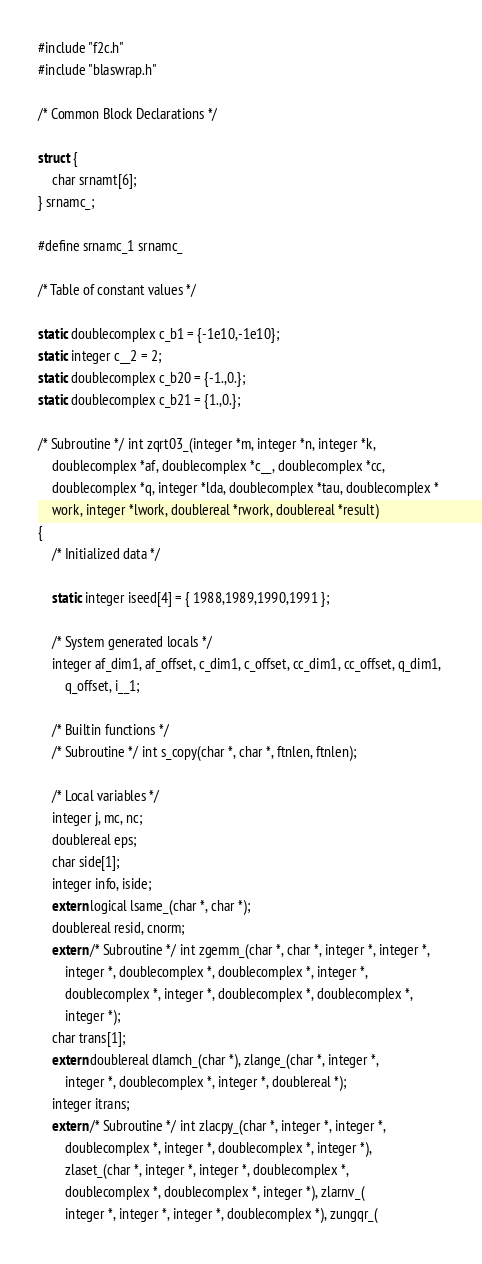Convert code to text. <code><loc_0><loc_0><loc_500><loc_500><_C_>#include "f2c.h"
#include "blaswrap.h"

/* Common Block Declarations */

struct {
    char srnamt[6];
} srnamc_;

#define srnamc_1 srnamc_

/* Table of constant values */

static doublecomplex c_b1 = {-1e10,-1e10};
static integer c__2 = 2;
static doublecomplex c_b20 = {-1.,0.};
static doublecomplex c_b21 = {1.,0.};

/* Subroutine */ int zqrt03_(integer *m, integer *n, integer *k, 
	doublecomplex *af, doublecomplex *c__, doublecomplex *cc, 
	doublecomplex *q, integer *lda, doublecomplex *tau, doublecomplex *
	work, integer *lwork, doublereal *rwork, doublereal *result)
{
    /* Initialized data */

    static integer iseed[4] = { 1988,1989,1990,1991 };

    /* System generated locals */
    integer af_dim1, af_offset, c_dim1, c_offset, cc_dim1, cc_offset, q_dim1, 
	    q_offset, i__1;

    /* Builtin functions */
    /* Subroutine */ int s_copy(char *, char *, ftnlen, ftnlen);

    /* Local variables */
    integer j, mc, nc;
    doublereal eps;
    char side[1];
    integer info, iside;
    extern logical lsame_(char *, char *);
    doublereal resid, cnorm;
    extern /* Subroutine */ int zgemm_(char *, char *, integer *, integer *, 
	    integer *, doublecomplex *, doublecomplex *, integer *, 
	    doublecomplex *, integer *, doublecomplex *, doublecomplex *, 
	    integer *);
    char trans[1];
    extern doublereal dlamch_(char *), zlange_(char *, integer *, 
	    integer *, doublecomplex *, integer *, doublereal *);
    integer itrans;
    extern /* Subroutine */ int zlacpy_(char *, integer *, integer *, 
	    doublecomplex *, integer *, doublecomplex *, integer *), 
	    zlaset_(char *, integer *, integer *, doublecomplex *, 
	    doublecomplex *, doublecomplex *, integer *), zlarnv_(
	    integer *, integer *, integer *, doublecomplex *), zungqr_(</code> 